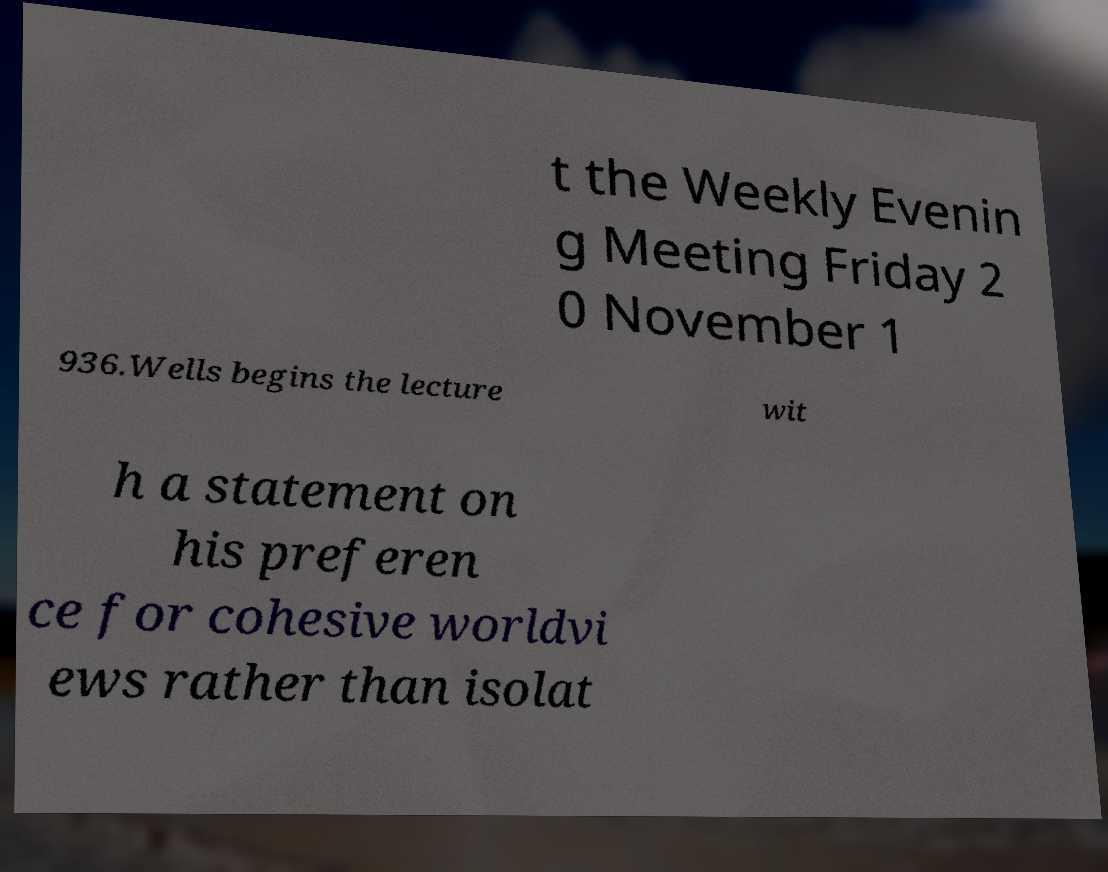Please identify and transcribe the text found in this image. t the Weekly Evenin g Meeting Friday 2 0 November 1 936.Wells begins the lecture wit h a statement on his preferen ce for cohesive worldvi ews rather than isolat 